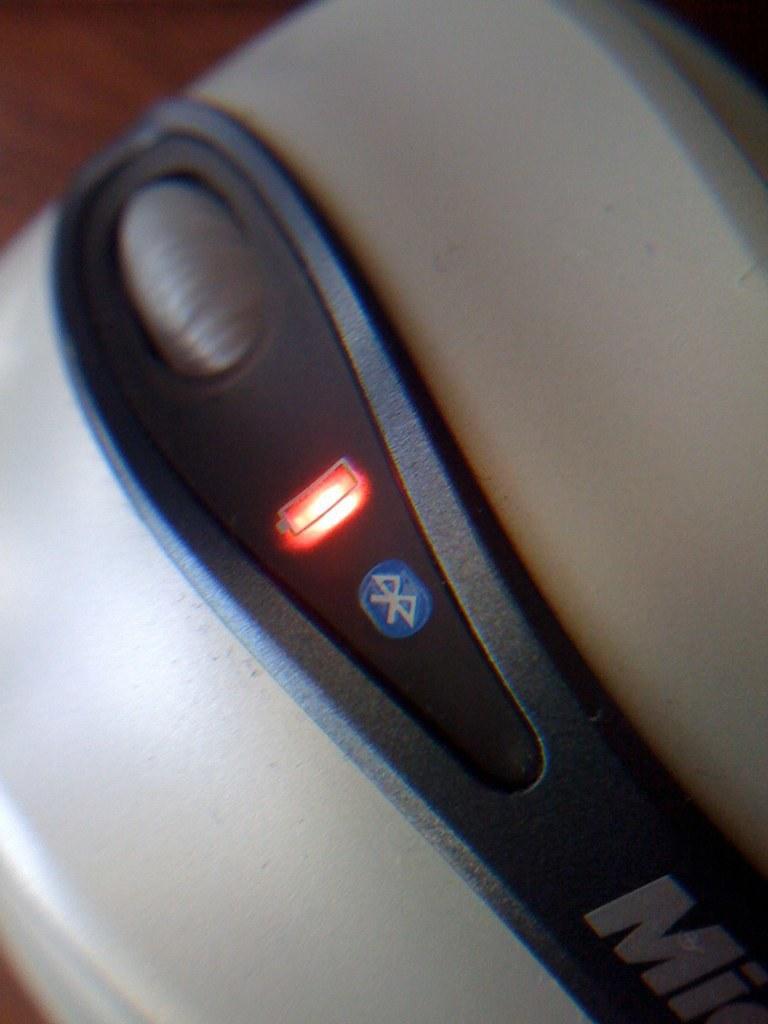Describe this image in one or two sentences. In the image there is a mouse and it has a Bluetooth connection. 